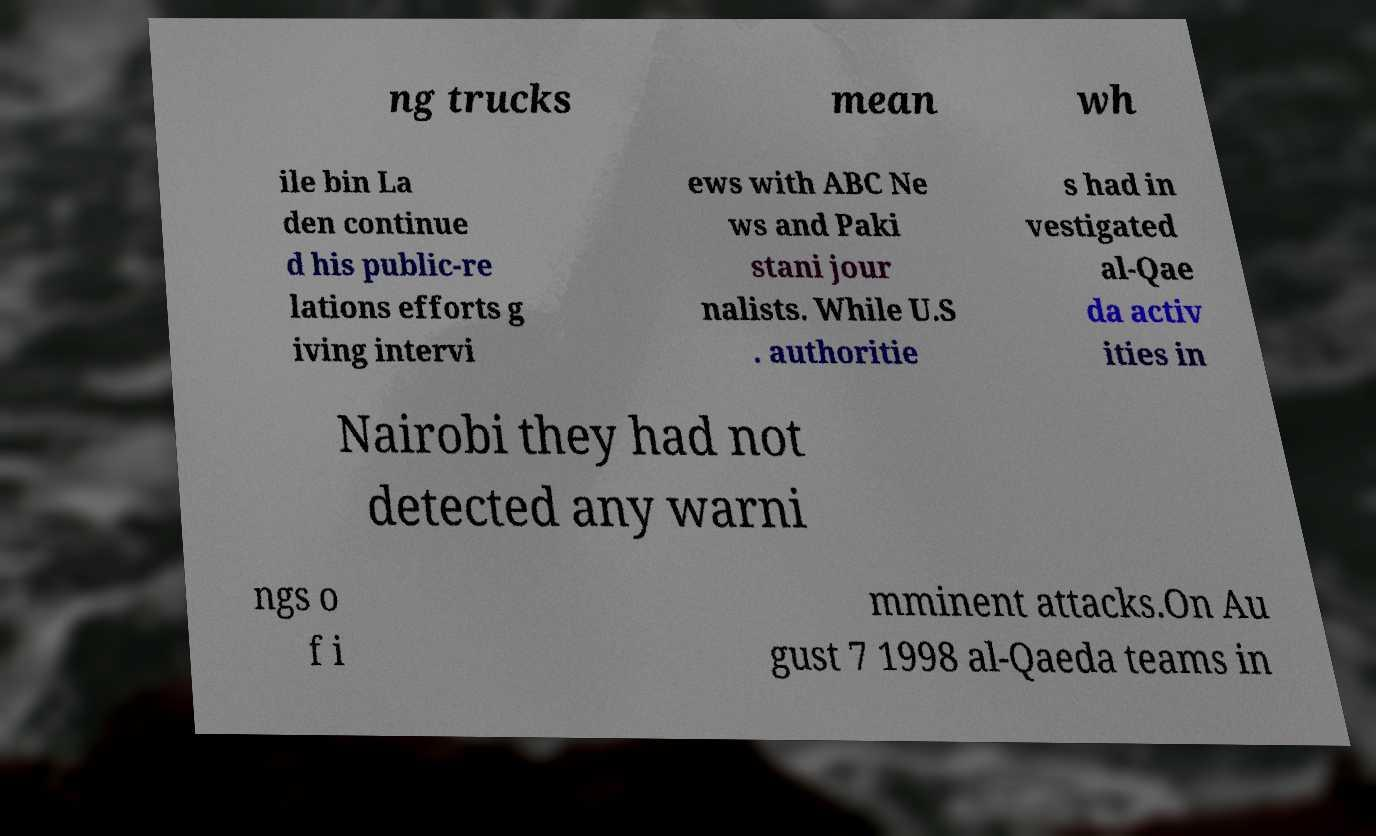Can you accurately transcribe the text from the provided image for me? ng trucks mean wh ile bin La den continue d his public-re lations efforts g iving intervi ews with ABC Ne ws and Paki stani jour nalists. While U.S . authoritie s had in vestigated al-Qae da activ ities in Nairobi they had not detected any warni ngs o f i mminent attacks.On Au gust 7 1998 al-Qaeda teams in 